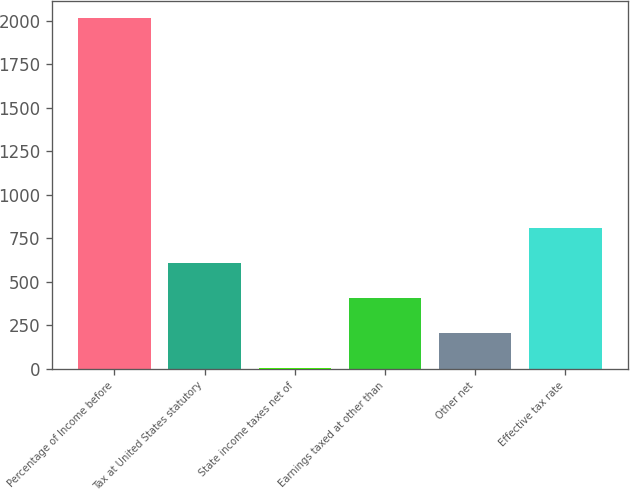Convert chart. <chart><loc_0><loc_0><loc_500><loc_500><bar_chart><fcel>Percentage of Income before<fcel>Tax at United States statutory<fcel>State income taxes net of<fcel>Earnings taxed at other than<fcel>Other net<fcel>Effective tax rate<nl><fcel>2015<fcel>605.2<fcel>1<fcel>403.8<fcel>202.4<fcel>806.6<nl></chart> 